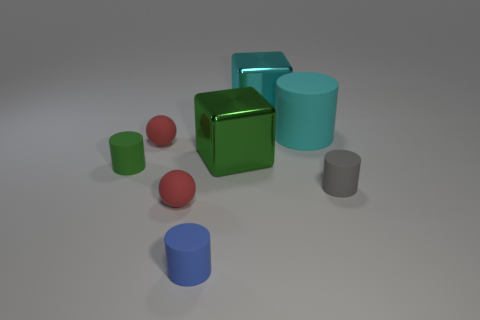Subtract all red spheres. How many were subtracted if there are1red spheres left? 1 Subtract 1 cylinders. How many cylinders are left? 3 Add 1 matte balls. How many objects exist? 9 Subtract all cubes. How many objects are left? 6 Subtract all small balls. Subtract all tiny gray objects. How many objects are left? 5 Add 4 cyan blocks. How many cyan blocks are left? 5 Add 1 blue things. How many blue things exist? 2 Subtract 0 purple balls. How many objects are left? 8 